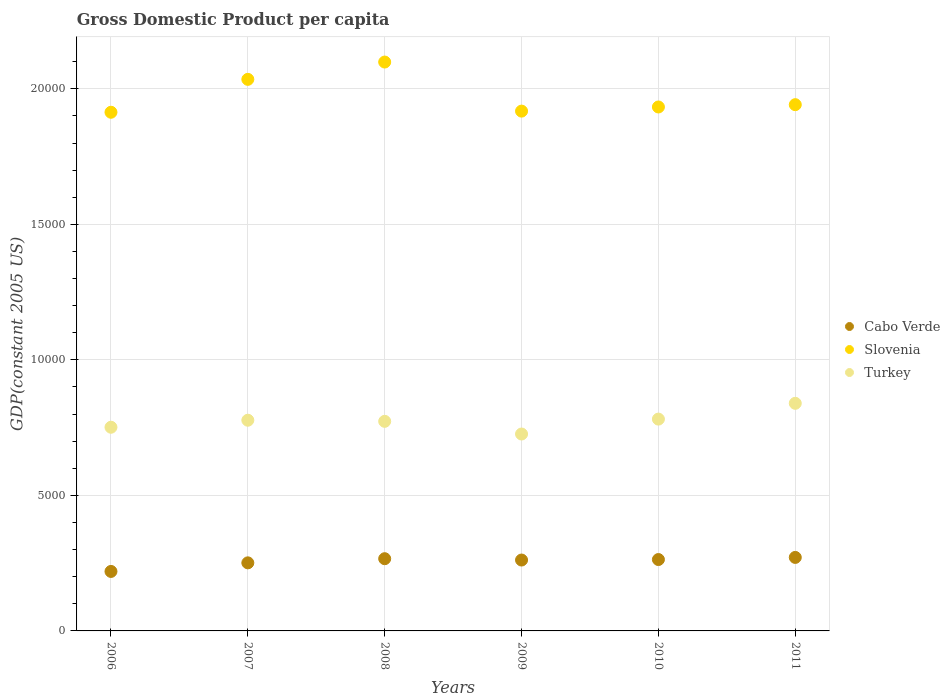What is the GDP per capita in Slovenia in 2009?
Provide a short and direct response. 1.92e+04. Across all years, what is the maximum GDP per capita in Slovenia?
Make the answer very short. 2.10e+04. Across all years, what is the minimum GDP per capita in Turkey?
Give a very brief answer. 7264.63. In which year was the GDP per capita in Cabo Verde minimum?
Offer a very short reply. 2006. What is the total GDP per capita in Turkey in the graph?
Your response must be concise. 4.65e+04. What is the difference between the GDP per capita in Cabo Verde in 2008 and that in 2010?
Your answer should be very brief. 30.94. What is the difference between the GDP per capita in Cabo Verde in 2010 and the GDP per capita in Slovenia in 2008?
Offer a very short reply. -1.84e+04. What is the average GDP per capita in Cabo Verde per year?
Ensure brevity in your answer.  2555.26. In the year 2010, what is the difference between the GDP per capita in Slovenia and GDP per capita in Cabo Verde?
Give a very brief answer. 1.67e+04. In how many years, is the GDP per capita in Cabo Verde greater than 7000 US$?
Make the answer very short. 0. What is the ratio of the GDP per capita in Slovenia in 2008 to that in 2009?
Your answer should be compact. 1.09. Is the GDP per capita in Turkey in 2006 less than that in 2008?
Offer a terse response. Yes. What is the difference between the highest and the second highest GDP per capita in Slovenia?
Give a very brief answer. 638.36. What is the difference between the highest and the lowest GDP per capita in Slovenia?
Your response must be concise. 1852.57. In how many years, is the GDP per capita in Cabo Verde greater than the average GDP per capita in Cabo Verde taken over all years?
Provide a succinct answer. 4. How many dotlines are there?
Provide a short and direct response. 3. Are the values on the major ticks of Y-axis written in scientific E-notation?
Make the answer very short. No. Does the graph contain any zero values?
Ensure brevity in your answer.  No. Does the graph contain grids?
Provide a short and direct response. Yes. How many legend labels are there?
Your answer should be compact. 3. How are the legend labels stacked?
Offer a terse response. Vertical. What is the title of the graph?
Keep it short and to the point. Gross Domestic Product per capita. Does "Spain" appear as one of the legend labels in the graph?
Provide a succinct answer. No. What is the label or title of the Y-axis?
Your response must be concise. GDP(constant 2005 US). What is the GDP(constant 2005 US) of Cabo Verde in 2006?
Your answer should be compact. 2194.55. What is the GDP(constant 2005 US) of Slovenia in 2006?
Your response must be concise. 1.91e+04. What is the GDP(constant 2005 US) of Turkey in 2006?
Offer a terse response. 7514.39. What is the GDP(constant 2005 US) in Cabo Verde in 2007?
Give a very brief answer. 2511.66. What is the GDP(constant 2005 US) in Slovenia in 2007?
Your response must be concise. 2.03e+04. What is the GDP(constant 2005 US) in Turkey in 2007?
Keep it short and to the point. 7773.47. What is the GDP(constant 2005 US) of Cabo Verde in 2008?
Keep it short and to the point. 2664.6. What is the GDP(constant 2005 US) of Slovenia in 2008?
Your answer should be very brief. 2.10e+04. What is the GDP(constant 2005 US) in Turkey in 2008?
Make the answer very short. 7732.49. What is the GDP(constant 2005 US) in Cabo Verde in 2009?
Provide a succinct answer. 2615.35. What is the GDP(constant 2005 US) in Slovenia in 2009?
Keep it short and to the point. 1.92e+04. What is the GDP(constant 2005 US) in Turkey in 2009?
Offer a terse response. 7264.63. What is the GDP(constant 2005 US) in Cabo Verde in 2010?
Keep it short and to the point. 2633.66. What is the GDP(constant 2005 US) of Slovenia in 2010?
Make the answer very short. 1.93e+04. What is the GDP(constant 2005 US) in Turkey in 2010?
Your response must be concise. 7814.8. What is the GDP(constant 2005 US) of Cabo Verde in 2011?
Offer a very short reply. 2711.75. What is the GDP(constant 2005 US) of Slovenia in 2011?
Ensure brevity in your answer.  1.94e+04. What is the GDP(constant 2005 US) in Turkey in 2011?
Offer a very short reply. 8397.14. Across all years, what is the maximum GDP(constant 2005 US) in Cabo Verde?
Your answer should be very brief. 2711.75. Across all years, what is the maximum GDP(constant 2005 US) in Slovenia?
Your answer should be compact. 2.10e+04. Across all years, what is the maximum GDP(constant 2005 US) of Turkey?
Ensure brevity in your answer.  8397.14. Across all years, what is the minimum GDP(constant 2005 US) of Cabo Verde?
Offer a very short reply. 2194.55. Across all years, what is the minimum GDP(constant 2005 US) in Slovenia?
Give a very brief answer. 1.91e+04. Across all years, what is the minimum GDP(constant 2005 US) of Turkey?
Your answer should be compact. 7264.63. What is the total GDP(constant 2005 US) in Cabo Verde in the graph?
Provide a succinct answer. 1.53e+04. What is the total GDP(constant 2005 US) of Slovenia in the graph?
Keep it short and to the point. 1.18e+05. What is the total GDP(constant 2005 US) of Turkey in the graph?
Provide a short and direct response. 4.65e+04. What is the difference between the GDP(constant 2005 US) of Cabo Verde in 2006 and that in 2007?
Offer a very short reply. -317.11. What is the difference between the GDP(constant 2005 US) in Slovenia in 2006 and that in 2007?
Offer a terse response. -1214.21. What is the difference between the GDP(constant 2005 US) in Turkey in 2006 and that in 2007?
Provide a succinct answer. -259.08. What is the difference between the GDP(constant 2005 US) of Cabo Verde in 2006 and that in 2008?
Offer a very short reply. -470.05. What is the difference between the GDP(constant 2005 US) of Slovenia in 2006 and that in 2008?
Keep it short and to the point. -1852.57. What is the difference between the GDP(constant 2005 US) in Turkey in 2006 and that in 2008?
Offer a terse response. -218.1. What is the difference between the GDP(constant 2005 US) of Cabo Verde in 2006 and that in 2009?
Make the answer very short. -420.8. What is the difference between the GDP(constant 2005 US) in Slovenia in 2006 and that in 2009?
Keep it short and to the point. -41.93. What is the difference between the GDP(constant 2005 US) of Turkey in 2006 and that in 2009?
Your answer should be compact. 249.76. What is the difference between the GDP(constant 2005 US) in Cabo Verde in 2006 and that in 2010?
Keep it short and to the point. -439.11. What is the difference between the GDP(constant 2005 US) of Slovenia in 2006 and that in 2010?
Your answer should be very brief. -194.82. What is the difference between the GDP(constant 2005 US) in Turkey in 2006 and that in 2010?
Provide a succinct answer. -300.41. What is the difference between the GDP(constant 2005 US) of Cabo Verde in 2006 and that in 2011?
Offer a very short reply. -517.2. What is the difference between the GDP(constant 2005 US) in Slovenia in 2006 and that in 2011?
Provide a short and direct response. -279.97. What is the difference between the GDP(constant 2005 US) of Turkey in 2006 and that in 2011?
Offer a terse response. -882.75. What is the difference between the GDP(constant 2005 US) in Cabo Verde in 2007 and that in 2008?
Make the answer very short. -152.94. What is the difference between the GDP(constant 2005 US) of Slovenia in 2007 and that in 2008?
Provide a succinct answer. -638.36. What is the difference between the GDP(constant 2005 US) in Turkey in 2007 and that in 2008?
Ensure brevity in your answer.  40.98. What is the difference between the GDP(constant 2005 US) of Cabo Verde in 2007 and that in 2009?
Give a very brief answer. -103.69. What is the difference between the GDP(constant 2005 US) of Slovenia in 2007 and that in 2009?
Provide a succinct answer. 1172.28. What is the difference between the GDP(constant 2005 US) in Turkey in 2007 and that in 2009?
Keep it short and to the point. 508.84. What is the difference between the GDP(constant 2005 US) of Cabo Verde in 2007 and that in 2010?
Keep it short and to the point. -122. What is the difference between the GDP(constant 2005 US) of Slovenia in 2007 and that in 2010?
Give a very brief answer. 1019.39. What is the difference between the GDP(constant 2005 US) of Turkey in 2007 and that in 2010?
Offer a terse response. -41.33. What is the difference between the GDP(constant 2005 US) in Cabo Verde in 2007 and that in 2011?
Offer a terse response. -200.09. What is the difference between the GDP(constant 2005 US) of Slovenia in 2007 and that in 2011?
Keep it short and to the point. 934.24. What is the difference between the GDP(constant 2005 US) in Turkey in 2007 and that in 2011?
Your response must be concise. -623.67. What is the difference between the GDP(constant 2005 US) of Cabo Verde in 2008 and that in 2009?
Make the answer very short. 49.25. What is the difference between the GDP(constant 2005 US) in Slovenia in 2008 and that in 2009?
Keep it short and to the point. 1810.64. What is the difference between the GDP(constant 2005 US) of Turkey in 2008 and that in 2009?
Your answer should be very brief. 467.86. What is the difference between the GDP(constant 2005 US) of Cabo Verde in 2008 and that in 2010?
Provide a succinct answer. 30.94. What is the difference between the GDP(constant 2005 US) in Slovenia in 2008 and that in 2010?
Your response must be concise. 1657.75. What is the difference between the GDP(constant 2005 US) in Turkey in 2008 and that in 2010?
Offer a very short reply. -82.31. What is the difference between the GDP(constant 2005 US) of Cabo Verde in 2008 and that in 2011?
Offer a terse response. -47.15. What is the difference between the GDP(constant 2005 US) of Slovenia in 2008 and that in 2011?
Ensure brevity in your answer.  1572.6. What is the difference between the GDP(constant 2005 US) in Turkey in 2008 and that in 2011?
Provide a succinct answer. -664.66. What is the difference between the GDP(constant 2005 US) in Cabo Verde in 2009 and that in 2010?
Your response must be concise. -18.31. What is the difference between the GDP(constant 2005 US) of Slovenia in 2009 and that in 2010?
Your answer should be compact. -152.89. What is the difference between the GDP(constant 2005 US) of Turkey in 2009 and that in 2010?
Make the answer very short. -550.17. What is the difference between the GDP(constant 2005 US) in Cabo Verde in 2009 and that in 2011?
Your response must be concise. -96.4. What is the difference between the GDP(constant 2005 US) in Slovenia in 2009 and that in 2011?
Your response must be concise. -238.04. What is the difference between the GDP(constant 2005 US) in Turkey in 2009 and that in 2011?
Make the answer very short. -1132.51. What is the difference between the GDP(constant 2005 US) in Cabo Verde in 2010 and that in 2011?
Give a very brief answer. -78.09. What is the difference between the GDP(constant 2005 US) in Slovenia in 2010 and that in 2011?
Provide a short and direct response. -85.15. What is the difference between the GDP(constant 2005 US) of Turkey in 2010 and that in 2011?
Your response must be concise. -582.34. What is the difference between the GDP(constant 2005 US) in Cabo Verde in 2006 and the GDP(constant 2005 US) in Slovenia in 2007?
Provide a short and direct response. -1.82e+04. What is the difference between the GDP(constant 2005 US) of Cabo Verde in 2006 and the GDP(constant 2005 US) of Turkey in 2007?
Offer a very short reply. -5578.92. What is the difference between the GDP(constant 2005 US) in Slovenia in 2006 and the GDP(constant 2005 US) in Turkey in 2007?
Provide a short and direct response. 1.14e+04. What is the difference between the GDP(constant 2005 US) in Cabo Verde in 2006 and the GDP(constant 2005 US) in Slovenia in 2008?
Keep it short and to the point. -1.88e+04. What is the difference between the GDP(constant 2005 US) of Cabo Verde in 2006 and the GDP(constant 2005 US) of Turkey in 2008?
Offer a very short reply. -5537.94. What is the difference between the GDP(constant 2005 US) in Slovenia in 2006 and the GDP(constant 2005 US) in Turkey in 2008?
Your response must be concise. 1.14e+04. What is the difference between the GDP(constant 2005 US) in Cabo Verde in 2006 and the GDP(constant 2005 US) in Slovenia in 2009?
Provide a succinct answer. -1.70e+04. What is the difference between the GDP(constant 2005 US) of Cabo Verde in 2006 and the GDP(constant 2005 US) of Turkey in 2009?
Keep it short and to the point. -5070.08. What is the difference between the GDP(constant 2005 US) in Slovenia in 2006 and the GDP(constant 2005 US) in Turkey in 2009?
Keep it short and to the point. 1.19e+04. What is the difference between the GDP(constant 2005 US) in Cabo Verde in 2006 and the GDP(constant 2005 US) in Slovenia in 2010?
Provide a short and direct response. -1.71e+04. What is the difference between the GDP(constant 2005 US) of Cabo Verde in 2006 and the GDP(constant 2005 US) of Turkey in 2010?
Your answer should be compact. -5620.25. What is the difference between the GDP(constant 2005 US) in Slovenia in 2006 and the GDP(constant 2005 US) in Turkey in 2010?
Offer a terse response. 1.13e+04. What is the difference between the GDP(constant 2005 US) of Cabo Verde in 2006 and the GDP(constant 2005 US) of Slovenia in 2011?
Offer a very short reply. -1.72e+04. What is the difference between the GDP(constant 2005 US) in Cabo Verde in 2006 and the GDP(constant 2005 US) in Turkey in 2011?
Your response must be concise. -6202.59. What is the difference between the GDP(constant 2005 US) in Slovenia in 2006 and the GDP(constant 2005 US) in Turkey in 2011?
Make the answer very short. 1.07e+04. What is the difference between the GDP(constant 2005 US) of Cabo Verde in 2007 and the GDP(constant 2005 US) of Slovenia in 2008?
Ensure brevity in your answer.  -1.85e+04. What is the difference between the GDP(constant 2005 US) in Cabo Verde in 2007 and the GDP(constant 2005 US) in Turkey in 2008?
Provide a succinct answer. -5220.83. What is the difference between the GDP(constant 2005 US) of Slovenia in 2007 and the GDP(constant 2005 US) of Turkey in 2008?
Your answer should be very brief. 1.26e+04. What is the difference between the GDP(constant 2005 US) in Cabo Verde in 2007 and the GDP(constant 2005 US) in Slovenia in 2009?
Offer a very short reply. -1.67e+04. What is the difference between the GDP(constant 2005 US) in Cabo Verde in 2007 and the GDP(constant 2005 US) in Turkey in 2009?
Make the answer very short. -4752.97. What is the difference between the GDP(constant 2005 US) in Slovenia in 2007 and the GDP(constant 2005 US) in Turkey in 2009?
Ensure brevity in your answer.  1.31e+04. What is the difference between the GDP(constant 2005 US) in Cabo Verde in 2007 and the GDP(constant 2005 US) in Slovenia in 2010?
Make the answer very short. -1.68e+04. What is the difference between the GDP(constant 2005 US) of Cabo Verde in 2007 and the GDP(constant 2005 US) of Turkey in 2010?
Give a very brief answer. -5303.14. What is the difference between the GDP(constant 2005 US) in Slovenia in 2007 and the GDP(constant 2005 US) in Turkey in 2010?
Give a very brief answer. 1.25e+04. What is the difference between the GDP(constant 2005 US) of Cabo Verde in 2007 and the GDP(constant 2005 US) of Slovenia in 2011?
Your response must be concise. -1.69e+04. What is the difference between the GDP(constant 2005 US) in Cabo Verde in 2007 and the GDP(constant 2005 US) in Turkey in 2011?
Your answer should be very brief. -5885.49. What is the difference between the GDP(constant 2005 US) in Slovenia in 2007 and the GDP(constant 2005 US) in Turkey in 2011?
Your answer should be very brief. 1.20e+04. What is the difference between the GDP(constant 2005 US) of Cabo Verde in 2008 and the GDP(constant 2005 US) of Slovenia in 2009?
Your response must be concise. -1.65e+04. What is the difference between the GDP(constant 2005 US) in Cabo Verde in 2008 and the GDP(constant 2005 US) in Turkey in 2009?
Your answer should be very brief. -4600.03. What is the difference between the GDP(constant 2005 US) in Slovenia in 2008 and the GDP(constant 2005 US) in Turkey in 2009?
Your answer should be compact. 1.37e+04. What is the difference between the GDP(constant 2005 US) of Cabo Verde in 2008 and the GDP(constant 2005 US) of Slovenia in 2010?
Your answer should be very brief. -1.67e+04. What is the difference between the GDP(constant 2005 US) in Cabo Verde in 2008 and the GDP(constant 2005 US) in Turkey in 2010?
Your response must be concise. -5150.2. What is the difference between the GDP(constant 2005 US) of Slovenia in 2008 and the GDP(constant 2005 US) of Turkey in 2010?
Offer a terse response. 1.32e+04. What is the difference between the GDP(constant 2005 US) in Cabo Verde in 2008 and the GDP(constant 2005 US) in Slovenia in 2011?
Provide a succinct answer. -1.68e+04. What is the difference between the GDP(constant 2005 US) in Cabo Verde in 2008 and the GDP(constant 2005 US) in Turkey in 2011?
Your answer should be compact. -5732.54. What is the difference between the GDP(constant 2005 US) of Slovenia in 2008 and the GDP(constant 2005 US) of Turkey in 2011?
Provide a short and direct response. 1.26e+04. What is the difference between the GDP(constant 2005 US) of Cabo Verde in 2009 and the GDP(constant 2005 US) of Slovenia in 2010?
Keep it short and to the point. -1.67e+04. What is the difference between the GDP(constant 2005 US) of Cabo Verde in 2009 and the GDP(constant 2005 US) of Turkey in 2010?
Offer a terse response. -5199.45. What is the difference between the GDP(constant 2005 US) of Slovenia in 2009 and the GDP(constant 2005 US) of Turkey in 2010?
Offer a very short reply. 1.14e+04. What is the difference between the GDP(constant 2005 US) in Cabo Verde in 2009 and the GDP(constant 2005 US) in Slovenia in 2011?
Offer a very short reply. -1.68e+04. What is the difference between the GDP(constant 2005 US) of Cabo Verde in 2009 and the GDP(constant 2005 US) of Turkey in 2011?
Ensure brevity in your answer.  -5781.8. What is the difference between the GDP(constant 2005 US) of Slovenia in 2009 and the GDP(constant 2005 US) of Turkey in 2011?
Offer a terse response. 1.08e+04. What is the difference between the GDP(constant 2005 US) of Cabo Verde in 2010 and the GDP(constant 2005 US) of Slovenia in 2011?
Keep it short and to the point. -1.68e+04. What is the difference between the GDP(constant 2005 US) of Cabo Verde in 2010 and the GDP(constant 2005 US) of Turkey in 2011?
Provide a succinct answer. -5763.49. What is the difference between the GDP(constant 2005 US) in Slovenia in 2010 and the GDP(constant 2005 US) in Turkey in 2011?
Offer a very short reply. 1.09e+04. What is the average GDP(constant 2005 US) in Cabo Verde per year?
Your response must be concise. 2555.26. What is the average GDP(constant 2005 US) of Slovenia per year?
Provide a succinct answer. 1.97e+04. What is the average GDP(constant 2005 US) of Turkey per year?
Offer a terse response. 7749.49. In the year 2006, what is the difference between the GDP(constant 2005 US) of Cabo Verde and GDP(constant 2005 US) of Slovenia?
Give a very brief answer. -1.69e+04. In the year 2006, what is the difference between the GDP(constant 2005 US) of Cabo Verde and GDP(constant 2005 US) of Turkey?
Offer a very short reply. -5319.84. In the year 2006, what is the difference between the GDP(constant 2005 US) of Slovenia and GDP(constant 2005 US) of Turkey?
Keep it short and to the point. 1.16e+04. In the year 2007, what is the difference between the GDP(constant 2005 US) of Cabo Verde and GDP(constant 2005 US) of Slovenia?
Offer a terse response. -1.78e+04. In the year 2007, what is the difference between the GDP(constant 2005 US) in Cabo Verde and GDP(constant 2005 US) in Turkey?
Provide a succinct answer. -5261.81. In the year 2007, what is the difference between the GDP(constant 2005 US) in Slovenia and GDP(constant 2005 US) in Turkey?
Your answer should be compact. 1.26e+04. In the year 2008, what is the difference between the GDP(constant 2005 US) in Cabo Verde and GDP(constant 2005 US) in Slovenia?
Make the answer very short. -1.83e+04. In the year 2008, what is the difference between the GDP(constant 2005 US) in Cabo Verde and GDP(constant 2005 US) in Turkey?
Keep it short and to the point. -5067.89. In the year 2008, what is the difference between the GDP(constant 2005 US) in Slovenia and GDP(constant 2005 US) in Turkey?
Offer a very short reply. 1.33e+04. In the year 2009, what is the difference between the GDP(constant 2005 US) in Cabo Verde and GDP(constant 2005 US) in Slovenia?
Offer a terse response. -1.66e+04. In the year 2009, what is the difference between the GDP(constant 2005 US) of Cabo Verde and GDP(constant 2005 US) of Turkey?
Offer a terse response. -4649.28. In the year 2009, what is the difference between the GDP(constant 2005 US) in Slovenia and GDP(constant 2005 US) in Turkey?
Give a very brief answer. 1.19e+04. In the year 2010, what is the difference between the GDP(constant 2005 US) in Cabo Verde and GDP(constant 2005 US) in Slovenia?
Make the answer very short. -1.67e+04. In the year 2010, what is the difference between the GDP(constant 2005 US) in Cabo Verde and GDP(constant 2005 US) in Turkey?
Your answer should be compact. -5181.14. In the year 2010, what is the difference between the GDP(constant 2005 US) of Slovenia and GDP(constant 2005 US) of Turkey?
Your answer should be compact. 1.15e+04. In the year 2011, what is the difference between the GDP(constant 2005 US) in Cabo Verde and GDP(constant 2005 US) in Slovenia?
Your answer should be very brief. -1.67e+04. In the year 2011, what is the difference between the GDP(constant 2005 US) of Cabo Verde and GDP(constant 2005 US) of Turkey?
Provide a succinct answer. -5685.39. In the year 2011, what is the difference between the GDP(constant 2005 US) of Slovenia and GDP(constant 2005 US) of Turkey?
Offer a terse response. 1.10e+04. What is the ratio of the GDP(constant 2005 US) in Cabo Verde in 2006 to that in 2007?
Make the answer very short. 0.87. What is the ratio of the GDP(constant 2005 US) of Slovenia in 2006 to that in 2007?
Your answer should be very brief. 0.94. What is the ratio of the GDP(constant 2005 US) of Turkey in 2006 to that in 2007?
Your answer should be very brief. 0.97. What is the ratio of the GDP(constant 2005 US) of Cabo Verde in 2006 to that in 2008?
Make the answer very short. 0.82. What is the ratio of the GDP(constant 2005 US) of Slovenia in 2006 to that in 2008?
Make the answer very short. 0.91. What is the ratio of the GDP(constant 2005 US) of Turkey in 2006 to that in 2008?
Your response must be concise. 0.97. What is the ratio of the GDP(constant 2005 US) of Cabo Verde in 2006 to that in 2009?
Offer a terse response. 0.84. What is the ratio of the GDP(constant 2005 US) in Slovenia in 2006 to that in 2009?
Offer a terse response. 1. What is the ratio of the GDP(constant 2005 US) in Turkey in 2006 to that in 2009?
Provide a short and direct response. 1.03. What is the ratio of the GDP(constant 2005 US) in Slovenia in 2006 to that in 2010?
Keep it short and to the point. 0.99. What is the ratio of the GDP(constant 2005 US) in Turkey in 2006 to that in 2010?
Offer a very short reply. 0.96. What is the ratio of the GDP(constant 2005 US) in Cabo Verde in 2006 to that in 2011?
Offer a terse response. 0.81. What is the ratio of the GDP(constant 2005 US) in Slovenia in 2006 to that in 2011?
Ensure brevity in your answer.  0.99. What is the ratio of the GDP(constant 2005 US) in Turkey in 2006 to that in 2011?
Your answer should be very brief. 0.89. What is the ratio of the GDP(constant 2005 US) of Cabo Verde in 2007 to that in 2008?
Provide a succinct answer. 0.94. What is the ratio of the GDP(constant 2005 US) in Slovenia in 2007 to that in 2008?
Your response must be concise. 0.97. What is the ratio of the GDP(constant 2005 US) of Cabo Verde in 2007 to that in 2009?
Your answer should be compact. 0.96. What is the ratio of the GDP(constant 2005 US) of Slovenia in 2007 to that in 2009?
Keep it short and to the point. 1.06. What is the ratio of the GDP(constant 2005 US) in Turkey in 2007 to that in 2009?
Offer a terse response. 1.07. What is the ratio of the GDP(constant 2005 US) in Cabo Verde in 2007 to that in 2010?
Keep it short and to the point. 0.95. What is the ratio of the GDP(constant 2005 US) of Slovenia in 2007 to that in 2010?
Provide a short and direct response. 1.05. What is the ratio of the GDP(constant 2005 US) of Cabo Verde in 2007 to that in 2011?
Provide a succinct answer. 0.93. What is the ratio of the GDP(constant 2005 US) in Slovenia in 2007 to that in 2011?
Your answer should be compact. 1.05. What is the ratio of the GDP(constant 2005 US) in Turkey in 2007 to that in 2011?
Give a very brief answer. 0.93. What is the ratio of the GDP(constant 2005 US) of Cabo Verde in 2008 to that in 2009?
Ensure brevity in your answer.  1.02. What is the ratio of the GDP(constant 2005 US) in Slovenia in 2008 to that in 2009?
Give a very brief answer. 1.09. What is the ratio of the GDP(constant 2005 US) in Turkey in 2008 to that in 2009?
Offer a very short reply. 1.06. What is the ratio of the GDP(constant 2005 US) in Cabo Verde in 2008 to that in 2010?
Your response must be concise. 1.01. What is the ratio of the GDP(constant 2005 US) in Slovenia in 2008 to that in 2010?
Your response must be concise. 1.09. What is the ratio of the GDP(constant 2005 US) of Cabo Verde in 2008 to that in 2011?
Your answer should be very brief. 0.98. What is the ratio of the GDP(constant 2005 US) in Slovenia in 2008 to that in 2011?
Provide a short and direct response. 1.08. What is the ratio of the GDP(constant 2005 US) of Turkey in 2008 to that in 2011?
Offer a very short reply. 0.92. What is the ratio of the GDP(constant 2005 US) in Slovenia in 2009 to that in 2010?
Make the answer very short. 0.99. What is the ratio of the GDP(constant 2005 US) of Turkey in 2009 to that in 2010?
Your answer should be compact. 0.93. What is the ratio of the GDP(constant 2005 US) of Cabo Verde in 2009 to that in 2011?
Your answer should be compact. 0.96. What is the ratio of the GDP(constant 2005 US) in Turkey in 2009 to that in 2011?
Keep it short and to the point. 0.87. What is the ratio of the GDP(constant 2005 US) in Cabo Verde in 2010 to that in 2011?
Your answer should be compact. 0.97. What is the ratio of the GDP(constant 2005 US) in Slovenia in 2010 to that in 2011?
Your answer should be compact. 1. What is the ratio of the GDP(constant 2005 US) of Turkey in 2010 to that in 2011?
Offer a very short reply. 0.93. What is the difference between the highest and the second highest GDP(constant 2005 US) in Cabo Verde?
Provide a short and direct response. 47.15. What is the difference between the highest and the second highest GDP(constant 2005 US) in Slovenia?
Keep it short and to the point. 638.36. What is the difference between the highest and the second highest GDP(constant 2005 US) of Turkey?
Provide a short and direct response. 582.34. What is the difference between the highest and the lowest GDP(constant 2005 US) in Cabo Verde?
Keep it short and to the point. 517.2. What is the difference between the highest and the lowest GDP(constant 2005 US) in Slovenia?
Give a very brief answer. 1852.57. What is the difference between the highest and the lowest GDP(constant 2005 US) of Turkey?
Your answer should be very brief. 1132.51. 